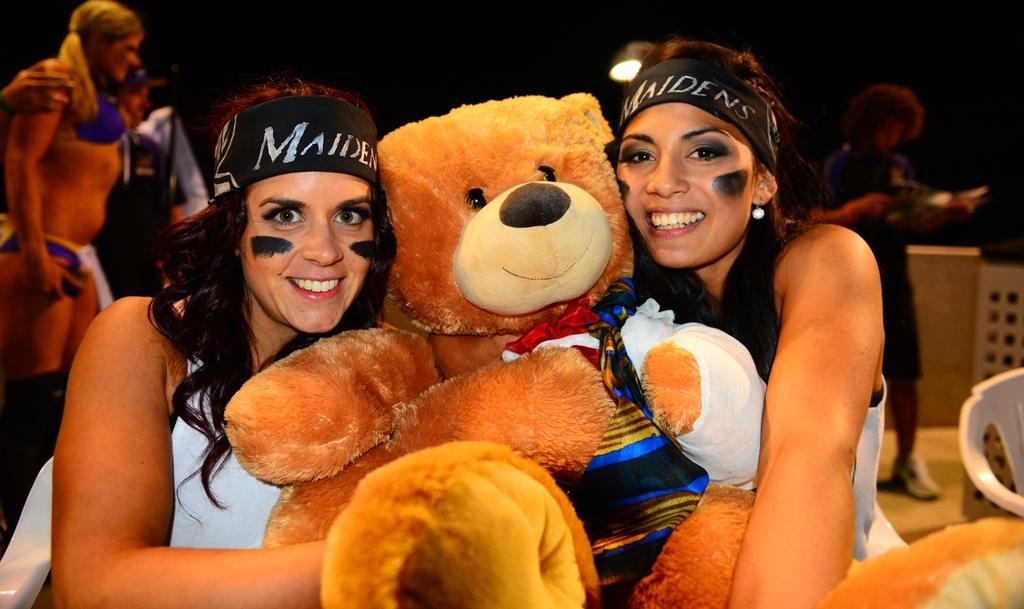Can you describe this image briefly? Here in this picture we can see two women sitting on chairs and they are holding a teddy bear in between them and both are smiling, behind them also we can see some people standing on the floor over there. 